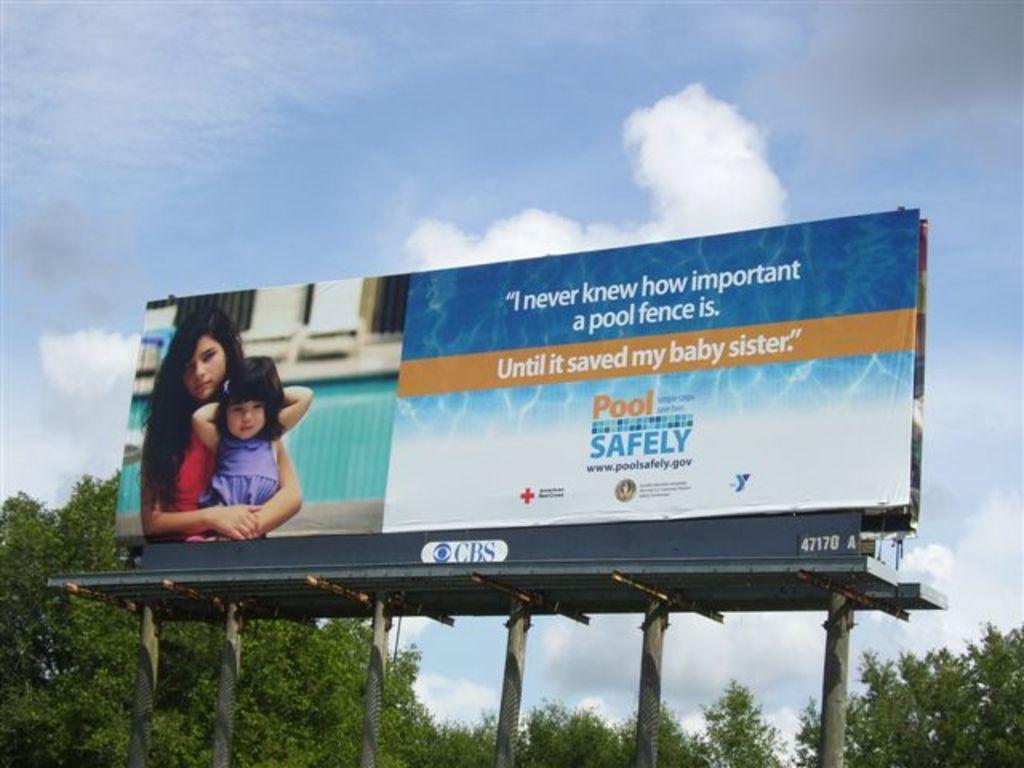What is this poster advertising?
Ensure brevity in your answer.  Pool safety. Who did it save?
Your answer should be compact. My baby sister. 